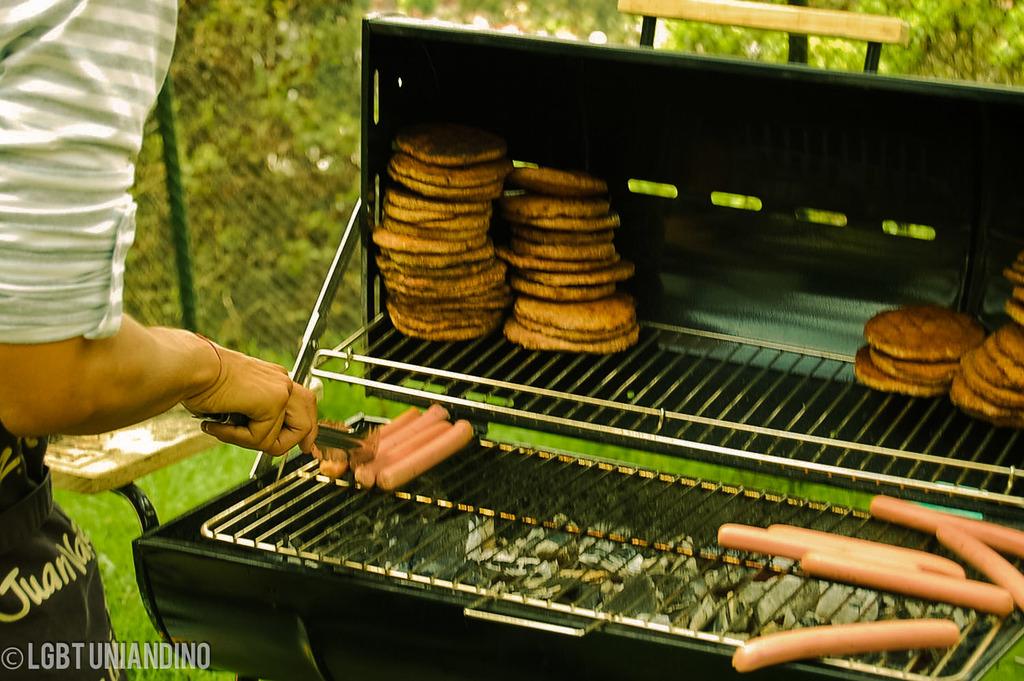Who took this photo?
Offer a terse response. Lgbt uniandino. 